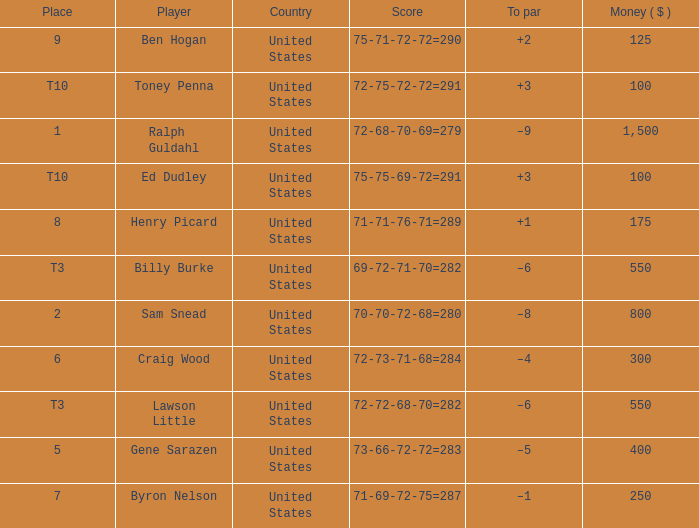Which country has a prize smaller than $250 and the player Henry Picard? United States. 